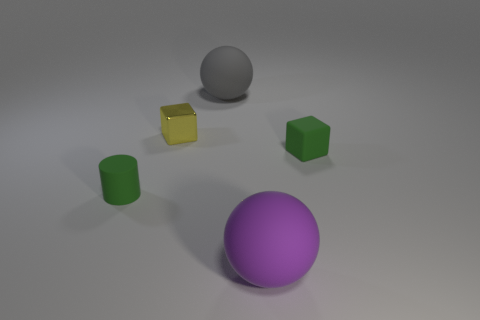What size is the object that is the same color as the tiny rubber cube?
Provide a succinct answer. Small. Are there fewer metal cubes that are in front of the purple matte thing than shiny cubes right of the cylinder?
Ensure brevity in your answer.  Yes. Is the color of the matte block the same as the metal cube?
Give a very brief answer. No. There is another large thing that is the same shape as the purple object; what is its color?
Make the answer very short. Gray. Is the color of the big thing in front of the green cylinder the same as the tiny shiny block?
Keep it short and to the point. No. Are there any matte cylinders of the same color as the shiny thing?
Provide a succinct answer. No. What number of small yellow objects are on the right side of the big purple thing?
Make the answer very short. 0. How many other things are the same size as the green rubber cylinder?
Offer a terse response. 2. Is the small cube that is right of the gray matte object made of the same material as the sphere in front of the tiny yellow shiny cube?
Give a very brief answer. Yes. There is a cube that is the same size as the yellow thing; what is its color?
Your answer should be compact. Green. 